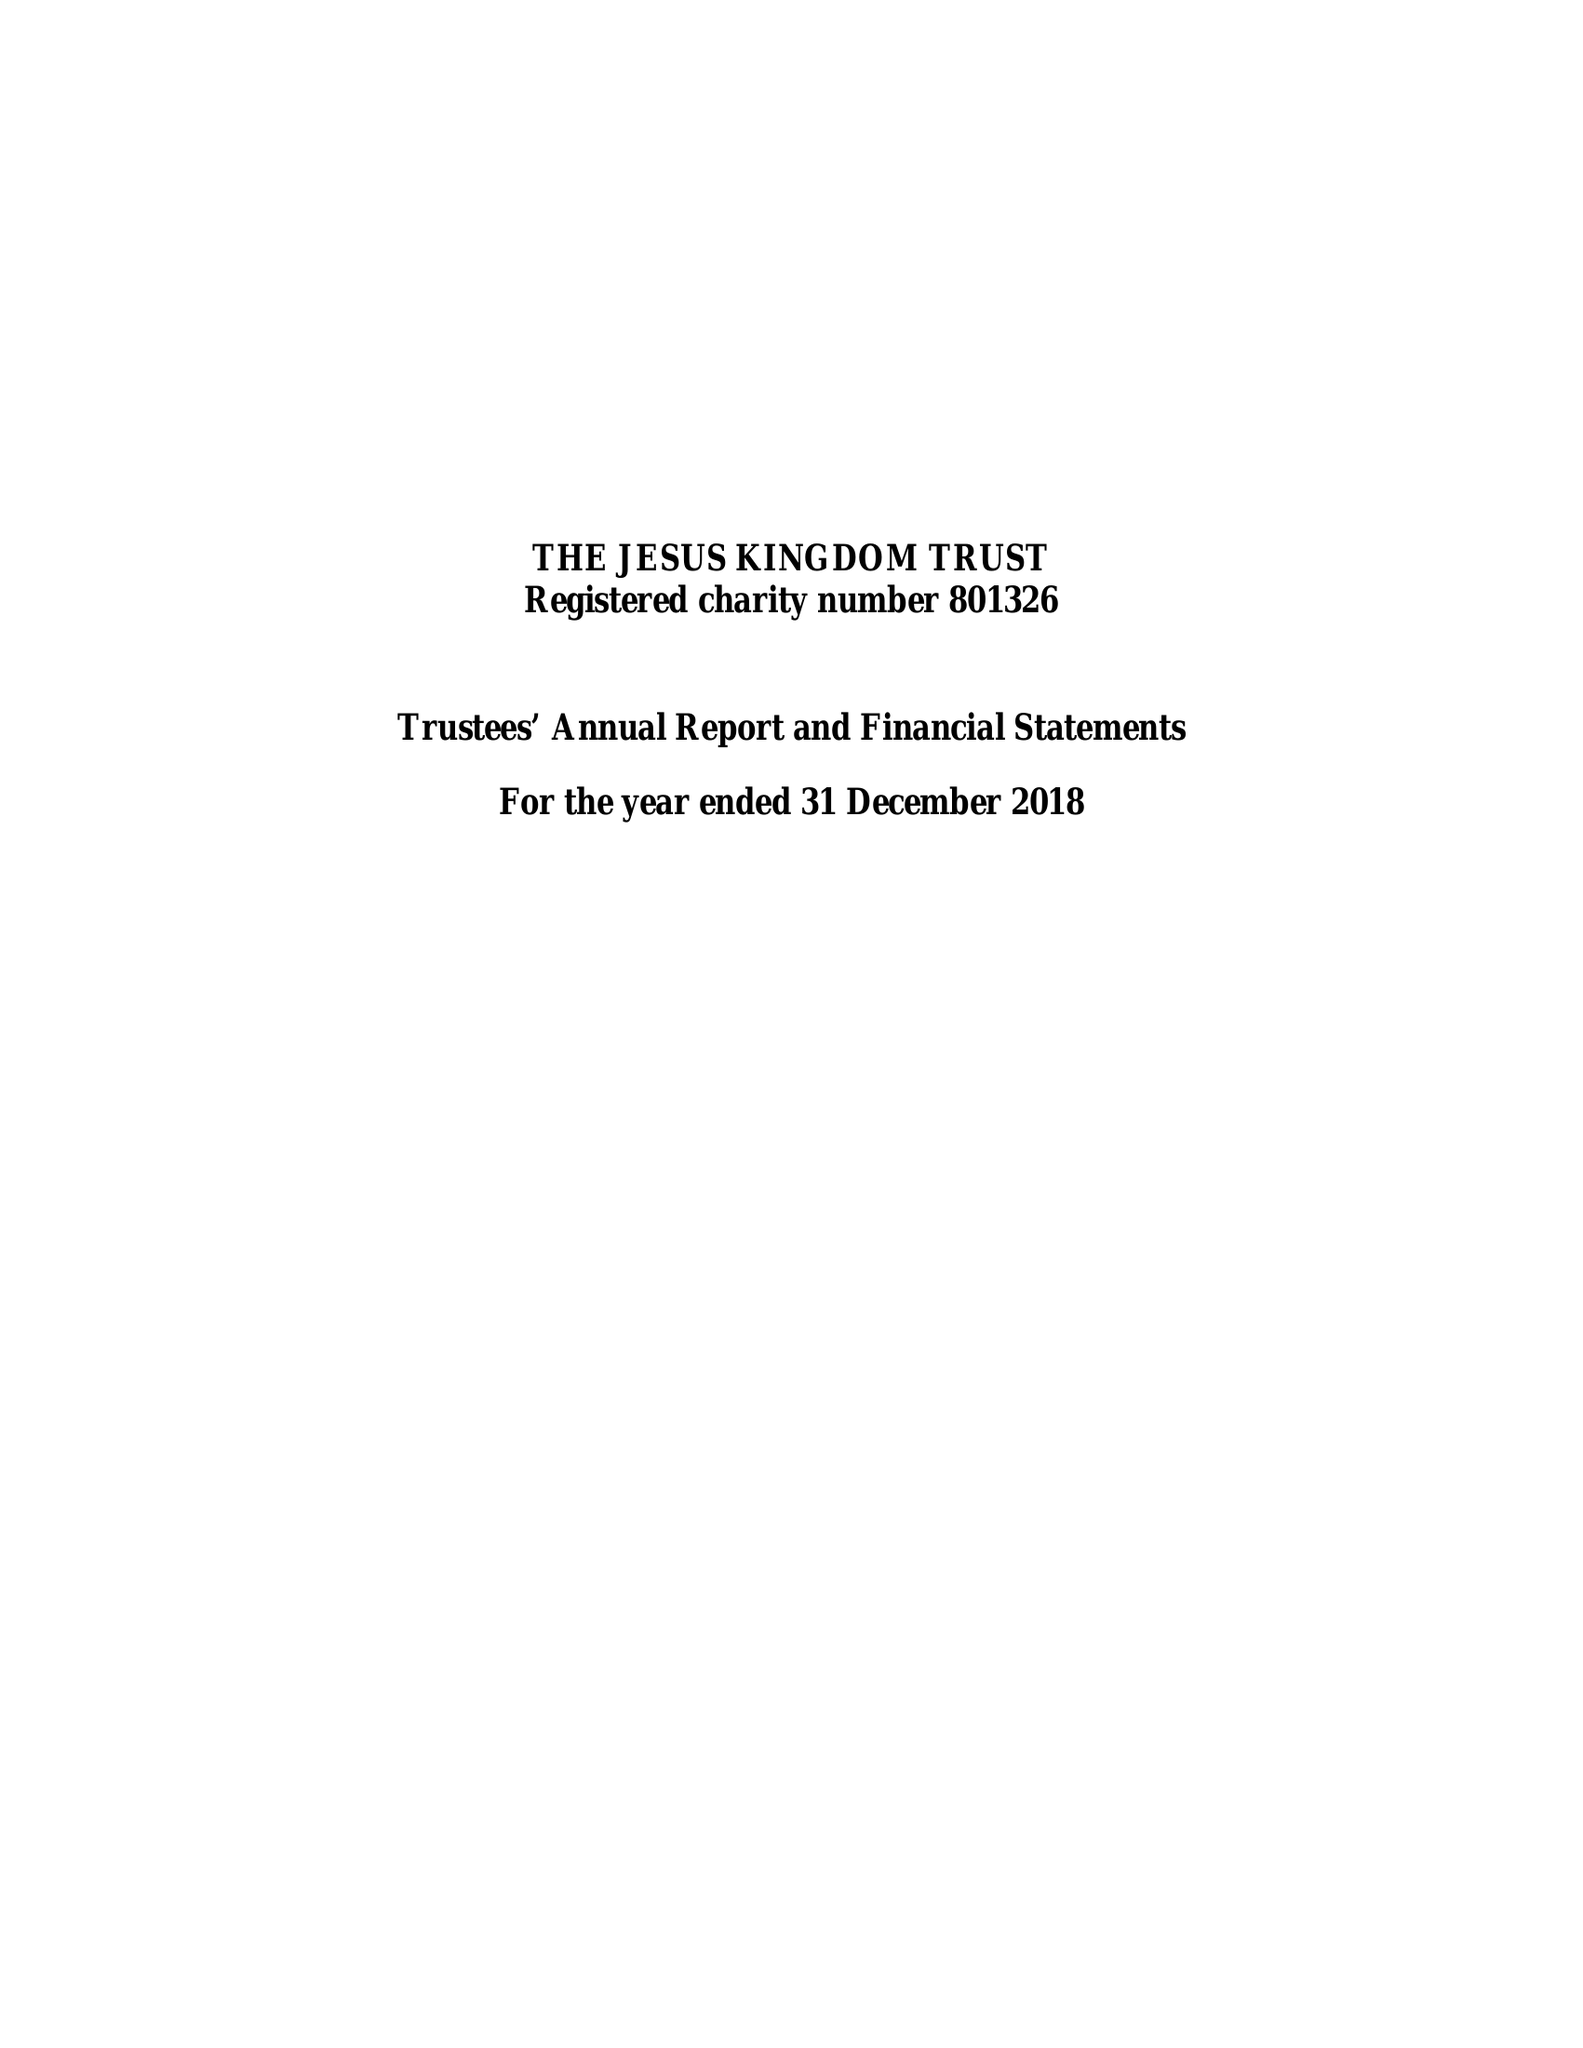What is the value for the charity_number?
Answer the question using a single word or phrase. 801326 